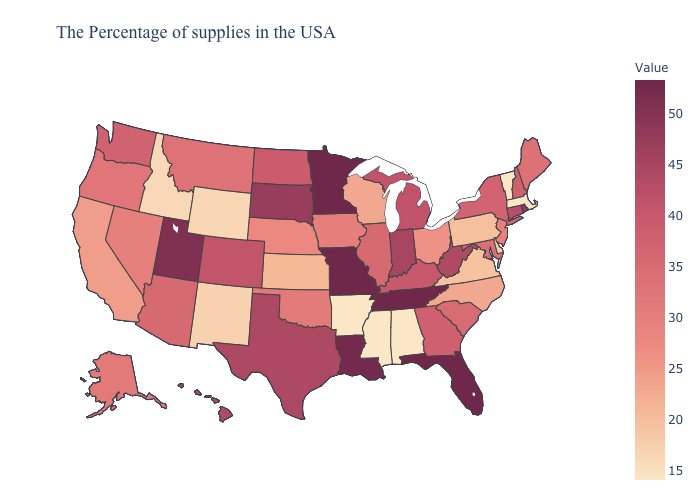Which states have the highest value in the USA?
Quick response, please. Florida, Tennessee, Missouri, Minnesota. Among the states that border Missouri , which have the highest value?
Concise answer only. Tennessee. Among the states that border Colorado , which have the highest value?
Keep it brief. Utah. Does Maine have the highest value in the Northeast?
Answer briefly. No. Does New York have the highest value in the Northeast?
Concise answer only. No. Does Arkansas have the lowest value in the South?
Quick response, please. Yes. Does Missouri have the highest value in the USA?
Give a very brief answer. Yes. 